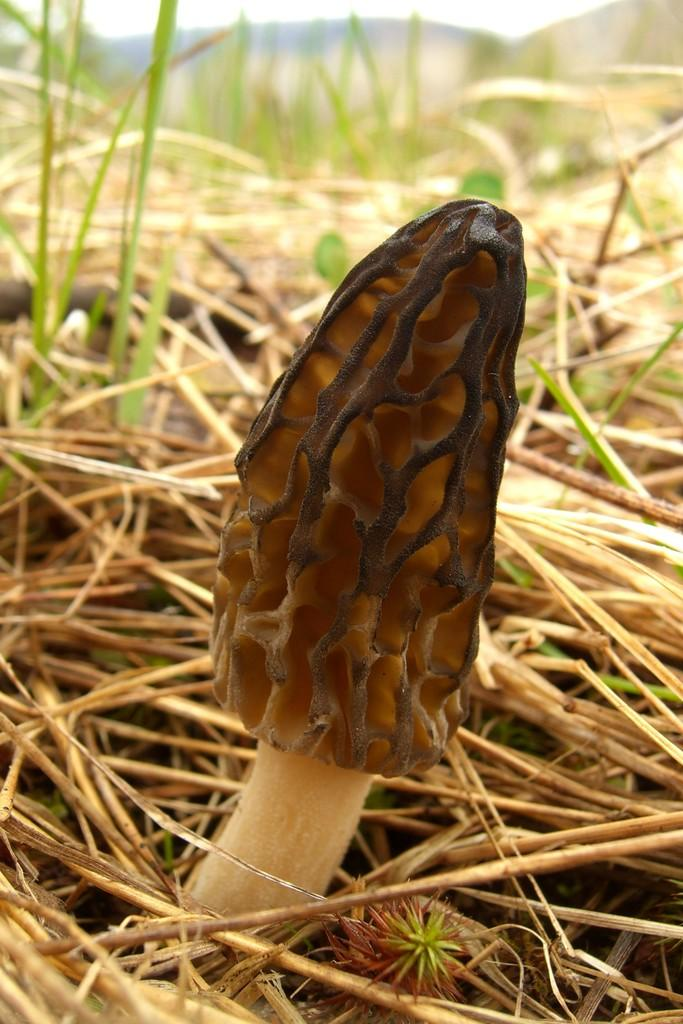What type of plant can be seen in the image? There is a mushroom in the image. What is the condition of the vegetation in the image? There is dry grass in the image. What type of cent is visible in the image? There is no cent present in the image. What role does the father play in the image? There is no father present in the image. 